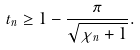<formula> <loc_0><loc_0><loc_500><loc_500>t _ { n } \geq 1 - \frac { \pi } { \sqrt { \chi _ { n } + 1 } } .</formula> 